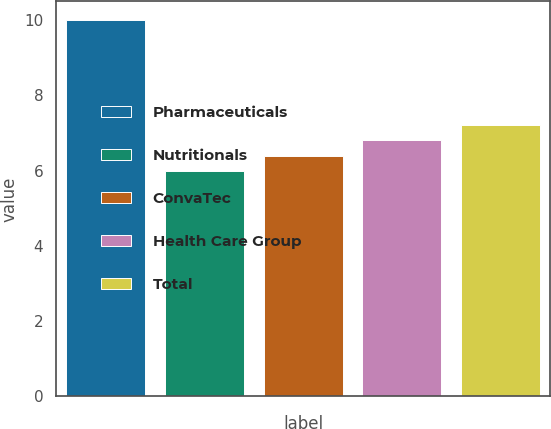Convert chart. <chart><loc_0><loc_0><loc_500><loc_500><bar_chart><fcel>Pharmaceuticals<fcel>Nutritionals<fcel>ConvaTec<fcel>Health Care Group<fcel>Total<nl><fcel>10<fcel>6<fcel>6.4<fcel>6.8<fcel>7.2<nl></chart> 